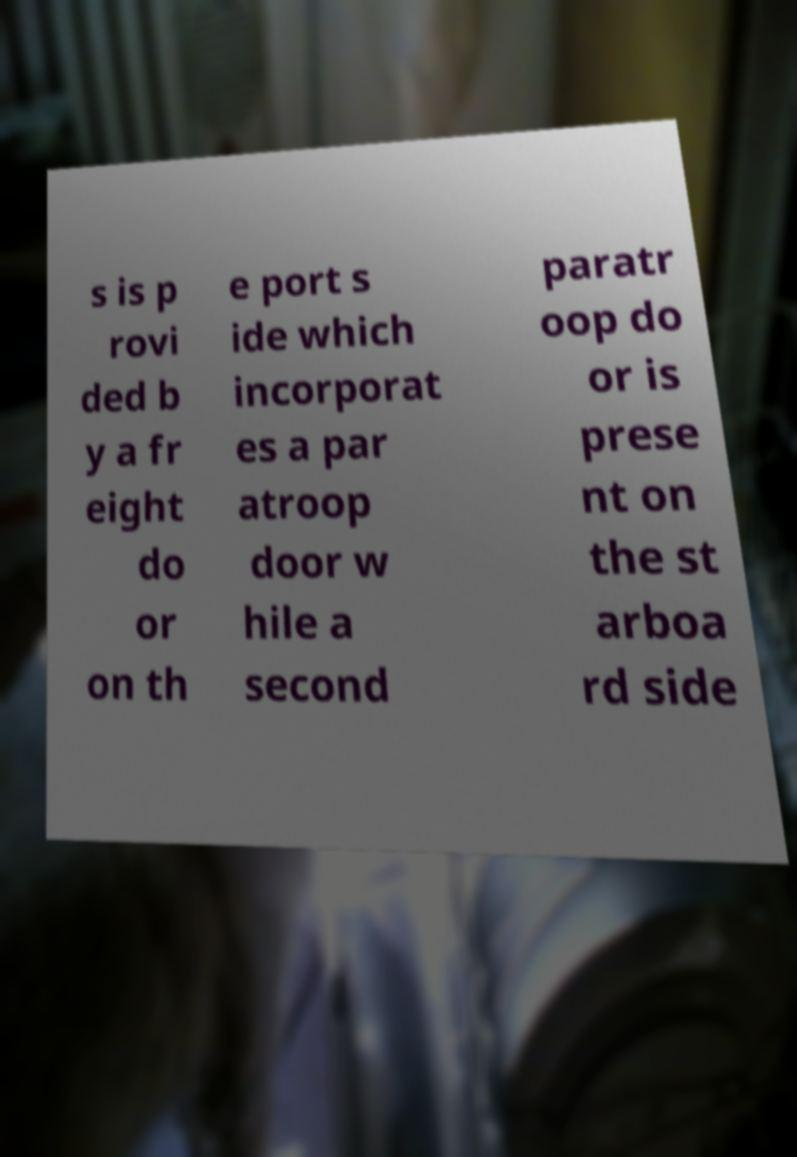Could you extract and type out the text from this image? s is p rovi ded b y a fr eight do or on th e port s ide which incorporat es a par atroop door w hile a second paratr oop do or is prese nt on the st arboa rd side 